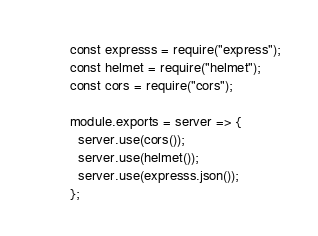Convert code to text. <code><loc_0><loc_0><loc_500><loc_500><_JavaScript_>const expresss = require("express");
const helmet = require("helmet");
const cors = require("cors");

module.exports = server => {
  server.use(cors());
  server.use(helmet());
  server.use(expresss.json());
};
</code> 